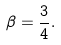Convert formula to latex. <formula><loc_0><loc_0><loc_500><loc_500>\beta = \frac { 3 } { 4 } .</formula> 